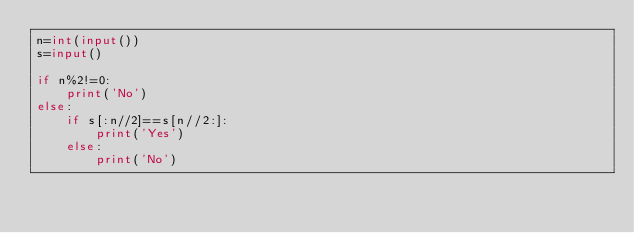<code> <loc_0><loc_0><loc_500><loc_500><_Python_>n=int(input())
s=input()

if n%2!=0:
    print('No')
else:
    if s[:n//2]==s[n//2:]:
        print('Yes')
    else:
        print('No')</code> 